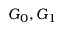Convert formula to latex. <formula><loc_0><loc_0><loc_500><loc_500>G _ { 0 } , G _ { 1 }</formula> 